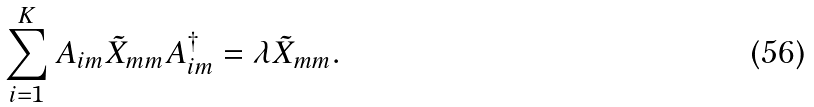<formula> <loc_0><loc_0><loc_500><loc_500>\sum _ { i = 1 } ^ { K } A _ { i m } \tilde { X } _ { m m } A _ { i m } ^ { \dagger } = \lambda \tilde { X } _ { m m } .</formula> 